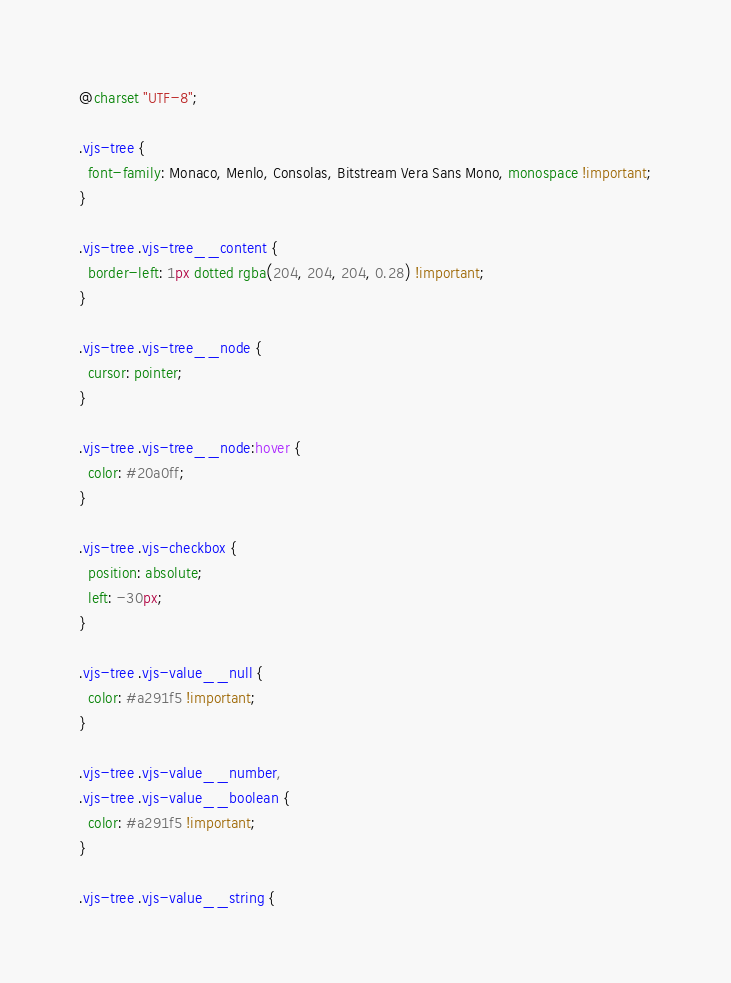<code> <loc_0><loc_0><loc_500><loc_500><_CSS_>@charset "UTF-8";

.vjs-tree {
  font-family: Monaco, Menlo, Consolas, Bitstream Vera Sans Mono, monospace !important;
}

.vjs-tree .vjs-tree__content {
  border-left: 1px dotted rgba(204, 204, 204, 0.28) !important;
}

.vjs-tree .vjs-tree__node {
  cursor: pointer;
}

.vjs-tree .vjs-tree__node:hover {
  color: #20a0ff;
}

.vjs-tree .vjs-checkbox {
  position: absolute;
  left: -30px;
}

.vjs-tree .vjs-value__null {
  color: #a291f5 !important;
}

.vjs-tree .vjs-value__number,
.vjs-tree .vjs-value__boolean {
  color: #a291f5 !important;
}

.vjs-tree .vjs-value__string {</code> 